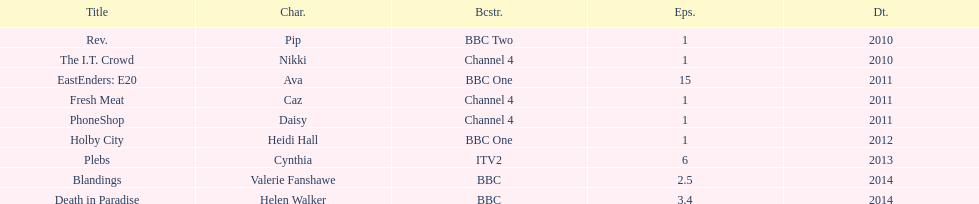Parse the table in full. {'header': ['Title', 'Char.', 'Bcstr.', 'Eps.', 'Dt.'], 'rows': [['Rev.', 'Pip', 'BBC Two', '1', '2010'], ['The I.T. Crowd', 'Nikki', 'Channel 4', '1', '2010'], ['EastEnders: E20', 'Ava', 'BBC One', '15', '2011'], ['Fresh Meat', 'Caz', 'Channel 4', '1', '2011'], ['PhoneShop', 'Daisy', 'Channel 4', '1', '2011'], ['Holby City', 'Heidi Hall', 'BBC One', '1', '2012'], ['Plebs', 'Cynthia', 'ITV2', '6', '2013'], ['Blandings', 'Valerie Fanshawe', 'BBC', '2.5', '2014'], ['Death in Paradise', 'Helen Walker', 'BBC', '3.4', '2014']]} What is the total number of shows sophie colguhoun appeared in? 9. 